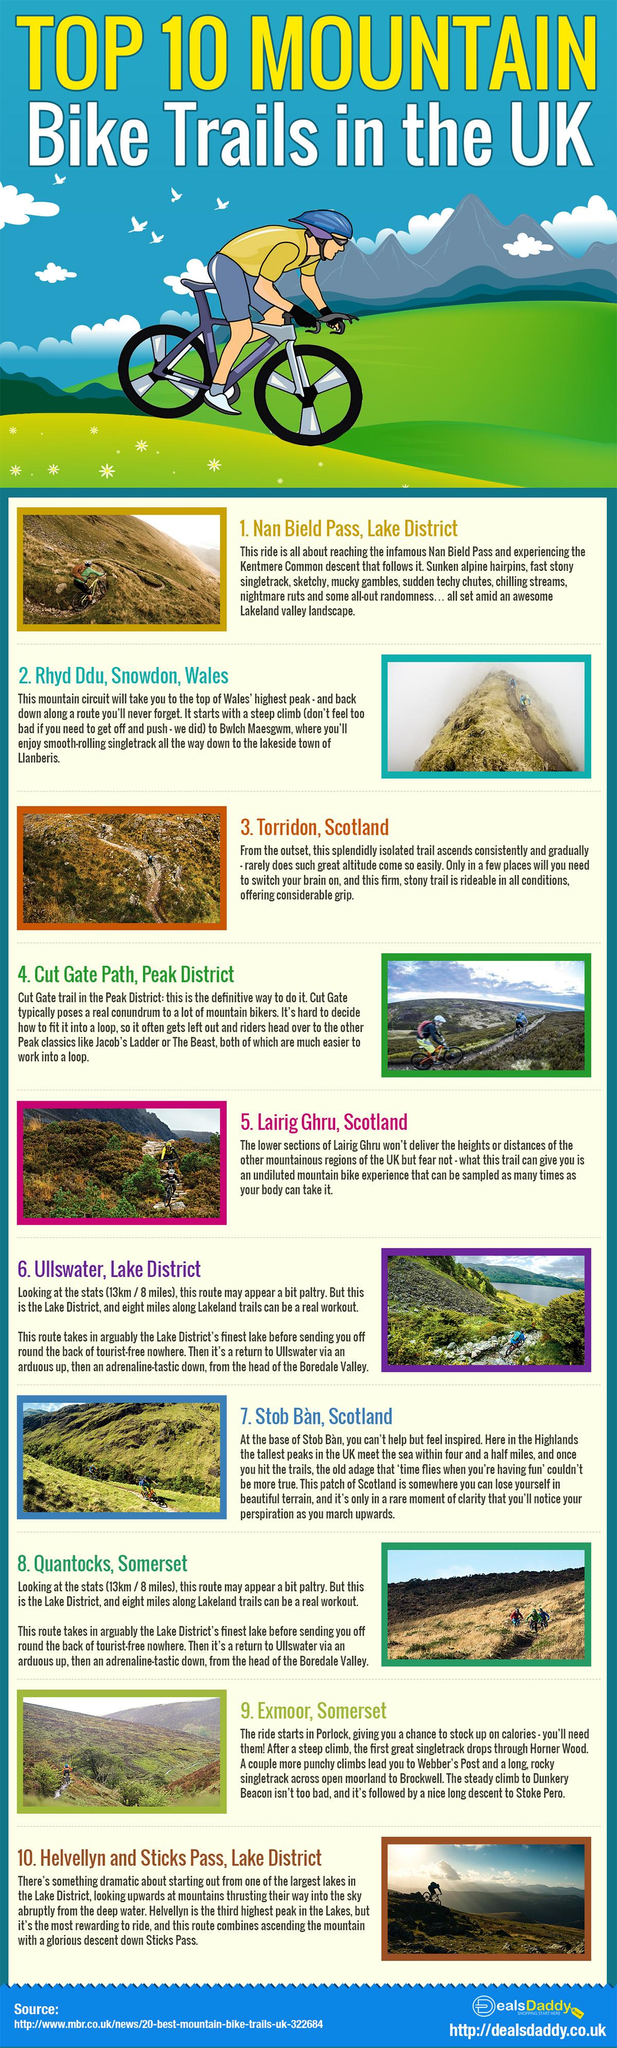Point out several critical features in this image. The mountain known as Lairig Ghru in Scotland is renowned for its exceptional bike trail, offering an unparalleled biking experience. The Ullswater mountain range offers a thrilling descent that is guaranteed to get your adrenaline pumping. 